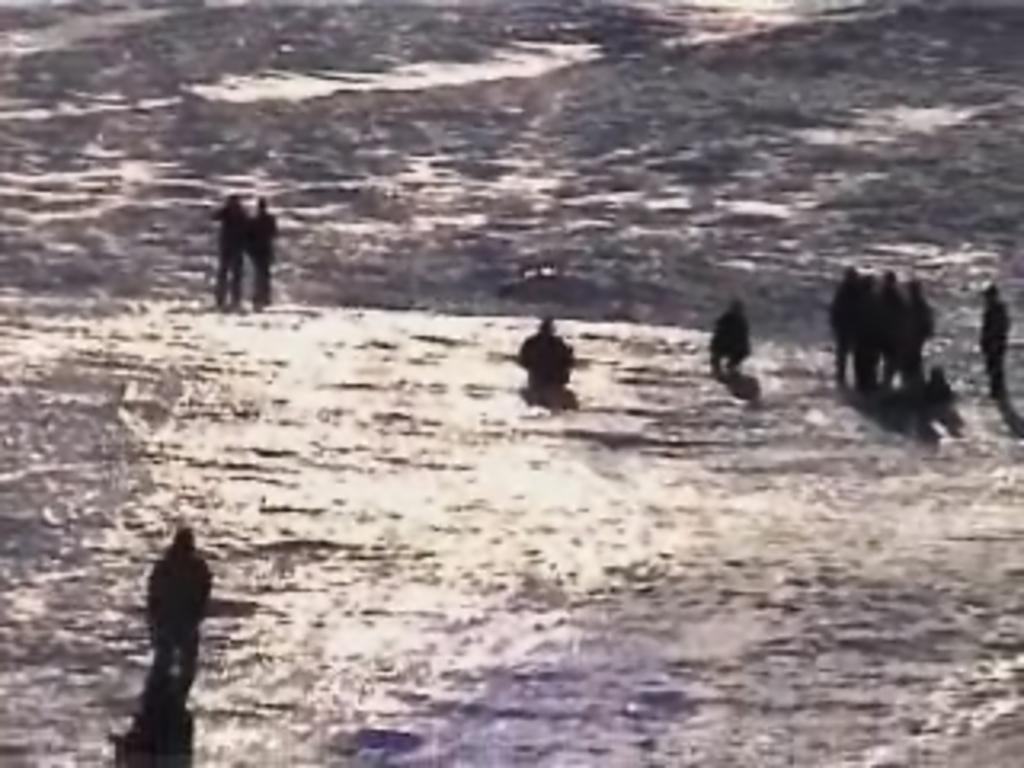How many people are in the image? There is a group of people in the image, but the exact number is not specified. What is the surface the people are standing on? The people are standing on snow. What type of brick is being used to build the dad's house in the image? There is no dad or house present in the image, so it is not possible to determine what type of brick might be used. 